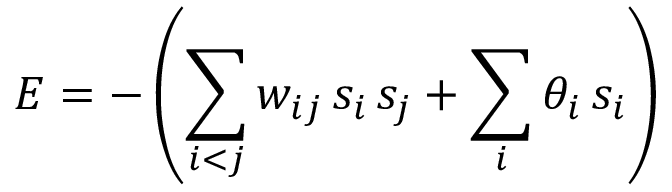Convert formula to latex. <formula><loc_0><loc_0><loc_500><loc_500>E = - \left ( \sum _ { i < j } w _ { i j } \, s _ { i } \, s _ { j } + \sum _ { i } \theta _ { i } \, s _ { i } \right )</formula> 